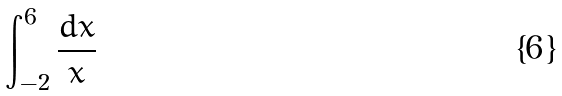Convert formula to latex. <formula><loc_0><loc_0><loc_500><loc_500>\int _ { - 2 } ^ { 6 } \frac { d x } { x }</formula> 